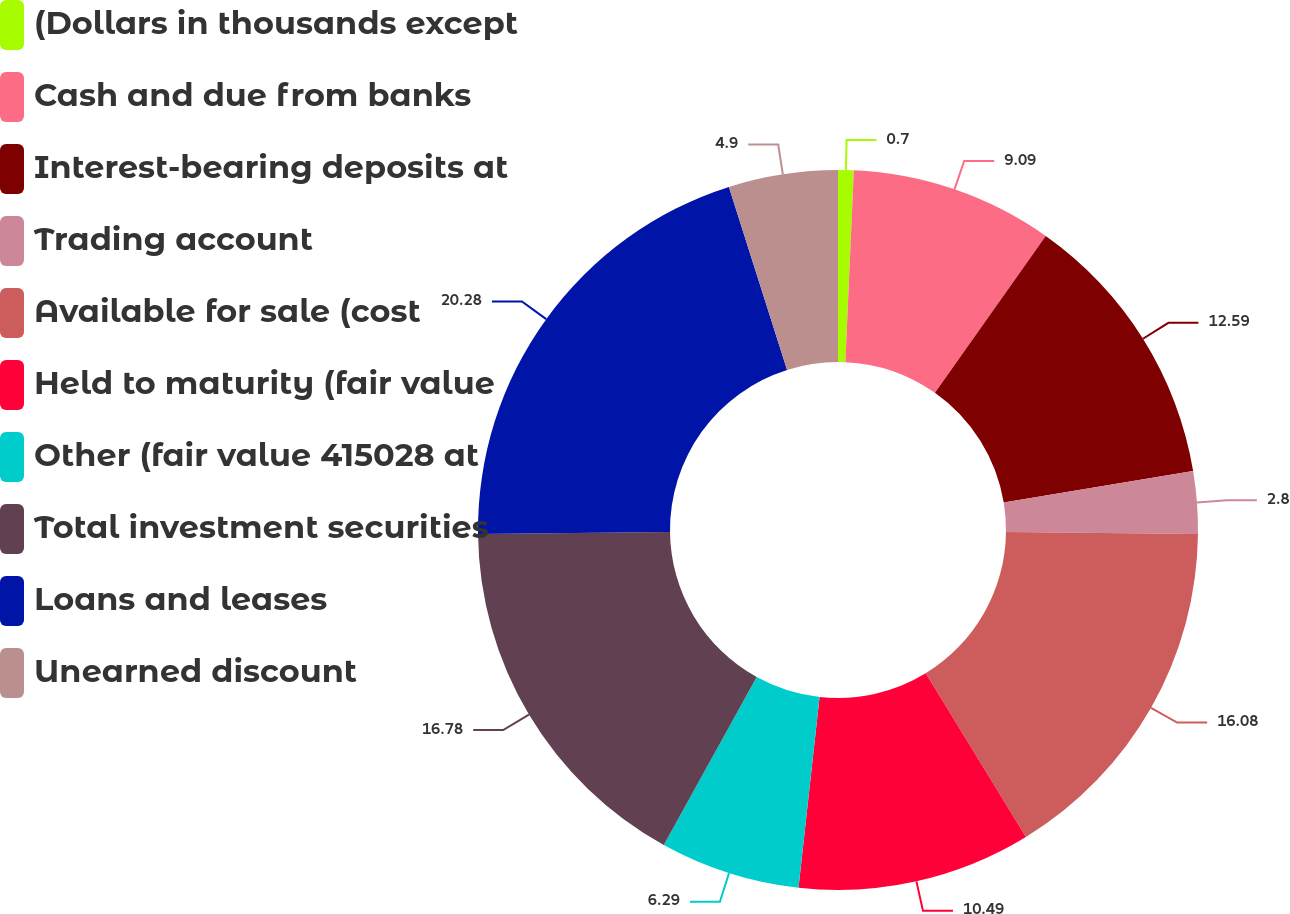Convert chart to OTSL. <chart><loc_0><loc_0><loc_500><loc_500><pie_chart><fcel>(Dollars in thousands except<fcel>Cash and due from banks<fcel>Interest-bearing deposits at<fcel>Trading account<fcel>Available for sale (cost<fcel>Held to maturity (fair value<fcel>Other (fair value 415028 at<fcel>Total investment securities<fcel>Loans and leases<fcel>Unearned discount<nl><fcel>0.7%<fcel>9.09%<fcel>12.59%<fcel>2.8%<fcel>16.08%<fcel>10.49%<fcel>6.29%<fcel>16.78%<fcel>20.28%<fcel>4.9%<nl></chart> 